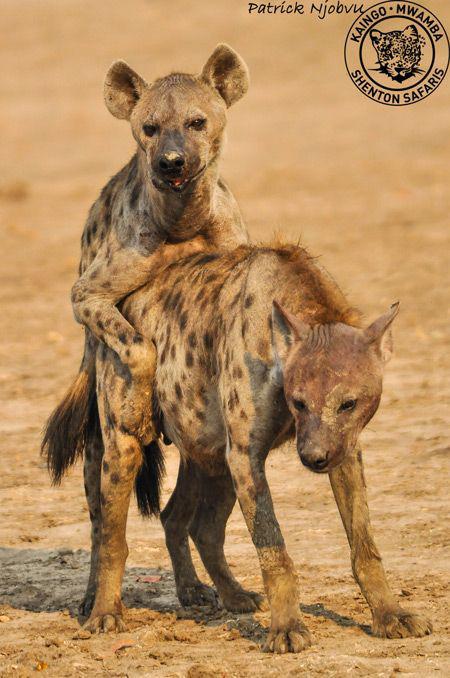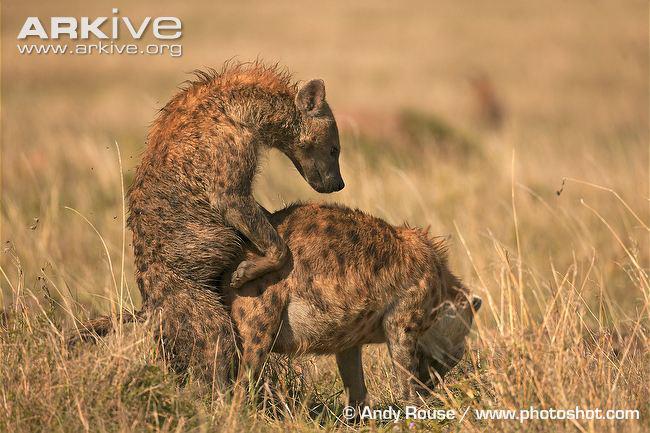The first image is the image on the left, the second image is the image on the right. For the images shown, is this caption "The hyena in the image on the left has something in its mouth." true? Answer yes or no. No. The first image is the image on the left, the second image is the image on the right. Given the left and right images, does the statement "The right image contains exactly two hyenas." hold true? Answer yes or no. Yes. 